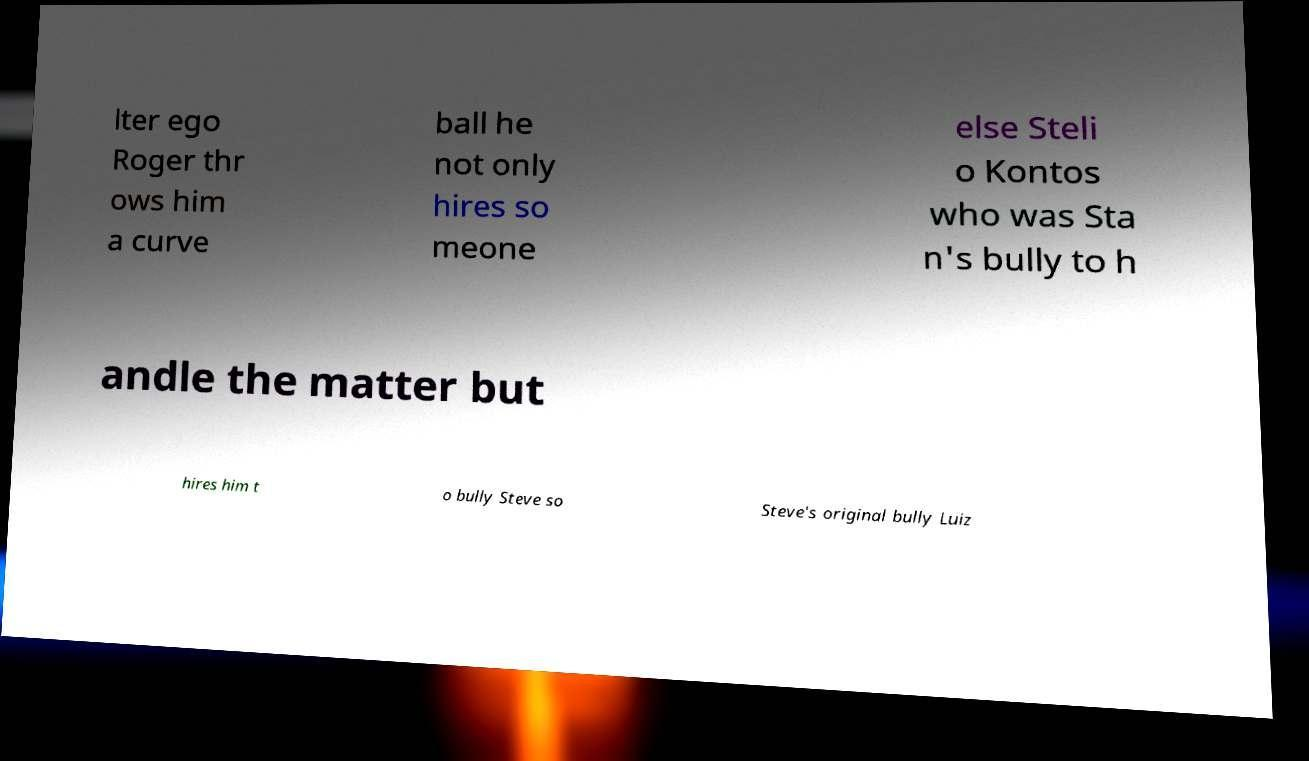For documentation purposes, I need the text within this image transcribed. Could you provide that? lter ego Roger thr ows him a curve ball he not only hires so meone else Steli o Kontos who was Sta n's bully to h andle the matter but hires him t o bully Steve so Steve's original bully Luiz 